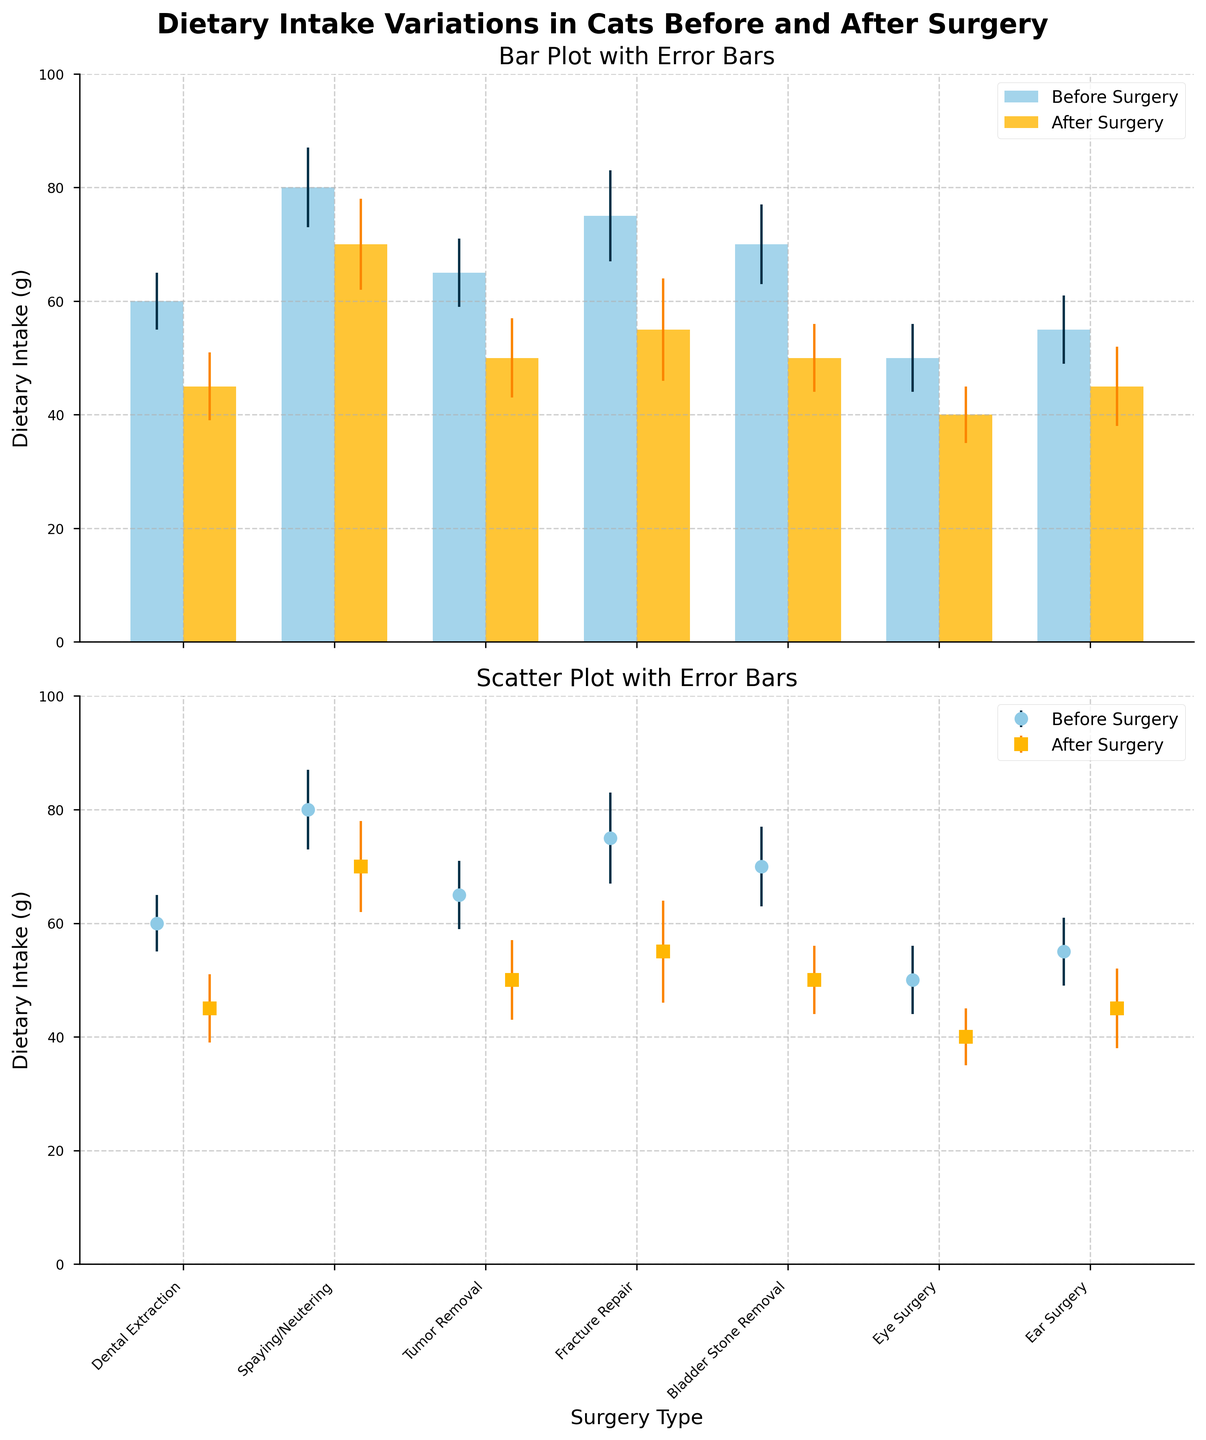What is the title of the upper subplot? The title of the upper subplot is shown at the top of the chart. It is a bar plot with error bars.
Answer: Bar Plot with Error Bars Which surgery type shows the highest mean dietary intake before surgery? By looking at the height of the bars representing "Before Surgery" in the bar plot, the tallest bar corresponds to "Spaying/Neutering."
Answer: Spaying/Neutering How do the dietary intakes compare before and after "Dental Extraction"? Look at the bars for "Dental Extraction." The before surgery bar is higher than the after surgery bar.
Answer: Before surgery is higher Which surgery type has the smallest standard deviation in dietary intake before surgery? Check the error bars on the "Before Surgery" series and look for the smallest error bar. "Dental Extraction" has the smallest stddev value.
Answer: Dental Extraction What is the total mean dietary intake for "Fracture Repair" before and after surgery? Add the mean values before (75g) and after (55g) surgery for "Fracture Repair."
Answer: 130g What is the average dietary intake decrease across all surgery types? Calculate the difference for each surgery type and then find the average. Differences: 15 (Dental Extraction), 10 (Spaying/Neutering), 15 (Tumor Removal), 20 (Fracture Repair), 20 (Bladder Stone Removal), 10 (Eye Surgery), 10 (Ear Surgery). Total decrease = 100, and there are 7 types.
Answer: 14.29g Which surgery type shows the largest spread (range of mean) in dietary intake before and after surgery? Determine the range of dietary intake (difference between before and after) for each surgery type. "Fracture Repair" shows the largest spread (75g before, 55g after, a difference of 20g).
Answer: Fracture Repair On the scatter plot, which surgery type data points for before and after surgery are closest to each other? On the scatter plot, find the data points for each surgery type where the before and after points are closest. "Ear Surgery" and "Dental Extraction" data points are very close. Specifically, "Ear Surgery" seems closest.
Answer: Ear Surgery Is the dietary intake after "Spaying/Neutering" higher than after "Fracture Repair"? Compare the heights of the "After Surgery" bars for "Spaying/Neutering" and "Fracture Repair." The bar for "Spaying/Neutering" is higher.
Answer: Yes Which plot type would be better for visualizing only the mean values without the error ranges? Since the user asked about visualizing only the mean values, a bar plot shows clear comparisons of mean values.
Answer: Bar Plot 